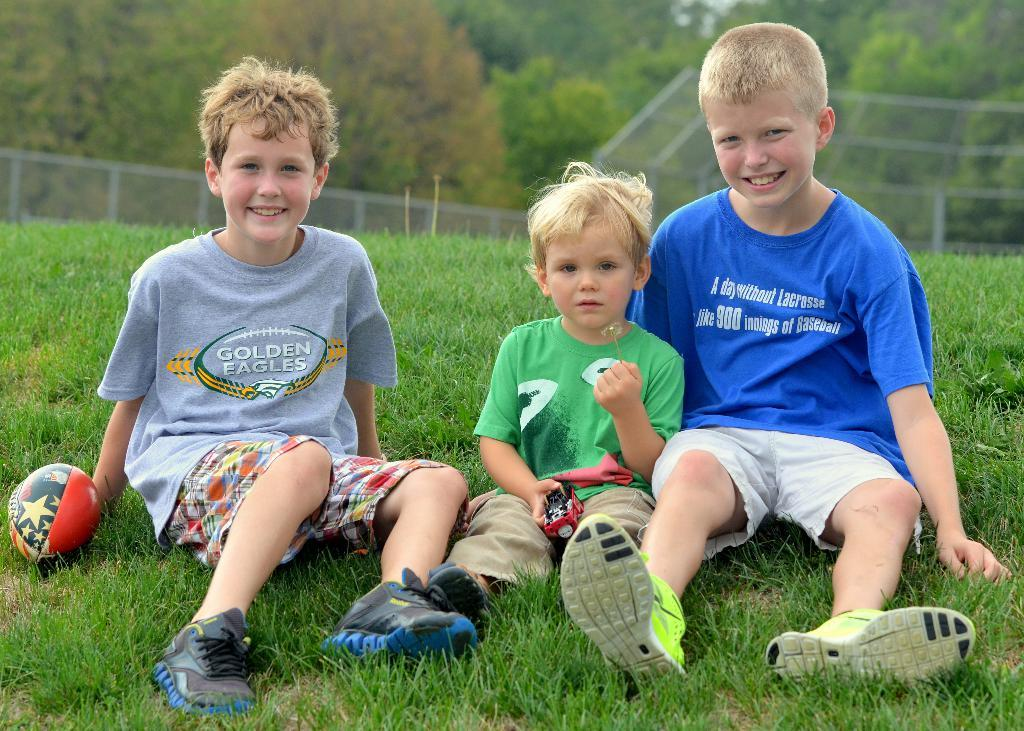How many people are in the image? There are a few people in the image. What can be seen on the ground in the image? The ground is visible in the image and has some grass. What type of vegetation is present in the image? There are a few trees in the image. What is the purpose of the fence in the image? The fence in the image serves as a boundary or barrier. What object is present in the image that might be used for playing? There is a ball in the image. What type of rice is being served in the prison in the image? There is no prison or rice present in the image; it features a few people, trees, a fence, and a ball. How many crates are visible in the image? There are no crates present in the image. 